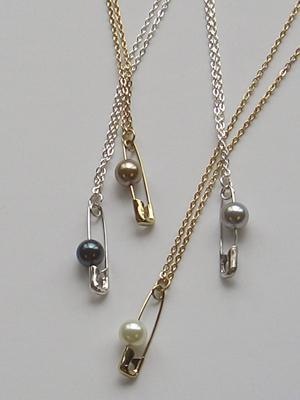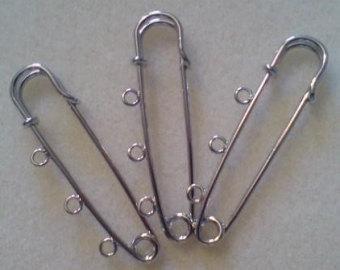The first image is the image on the left, the second image is the image on the right. Given the left and right images, does the statement "The left image contains exactly two unadorned, separate safety pins, and the right image contains exactly four safety pins." hold true? Answer yes or no. No. The first image is the image on the left, the second image is the image on the right. For the images displayed, is the sentence "Safety pins have be beaded to become fashion accessories. ." factually correct? Answer yes or no. Yes. 